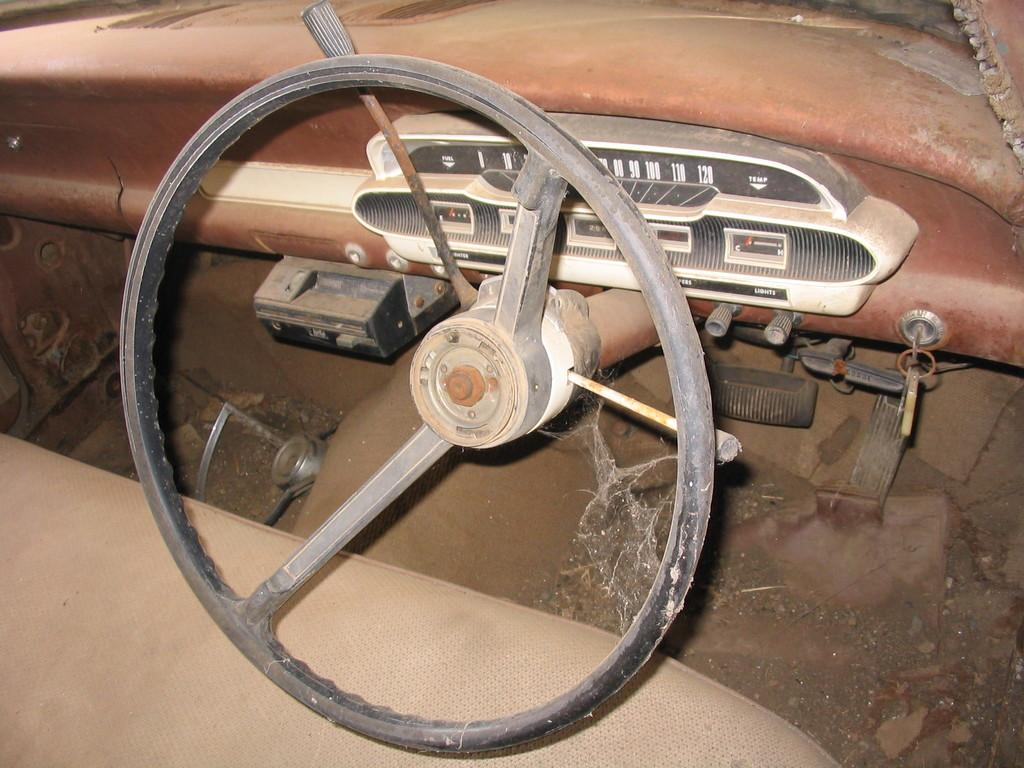What type of space is depicted in the image? The image shows the inside view of a vehicle. What is the primary control device in the vehicle? There is a steering wheel in the image. What objects are present in the vehicle that might be used for storage? There are boxes in the image. What type of interactive elements can be seen in the vehicle? There are buttons in the image. What is used to start the vehicle? There are keys in the image. What structural elements can be seen in the vehicle? There are rods in the image. What type of seating is available in the vehicle? There is a seat in the image. What additional feature is visible in the image? There is a web visible in the image. Where is the bee located in the image? There is no bee present in the image. What part of the brain can be seen in the image? There is no brain present in the image. 